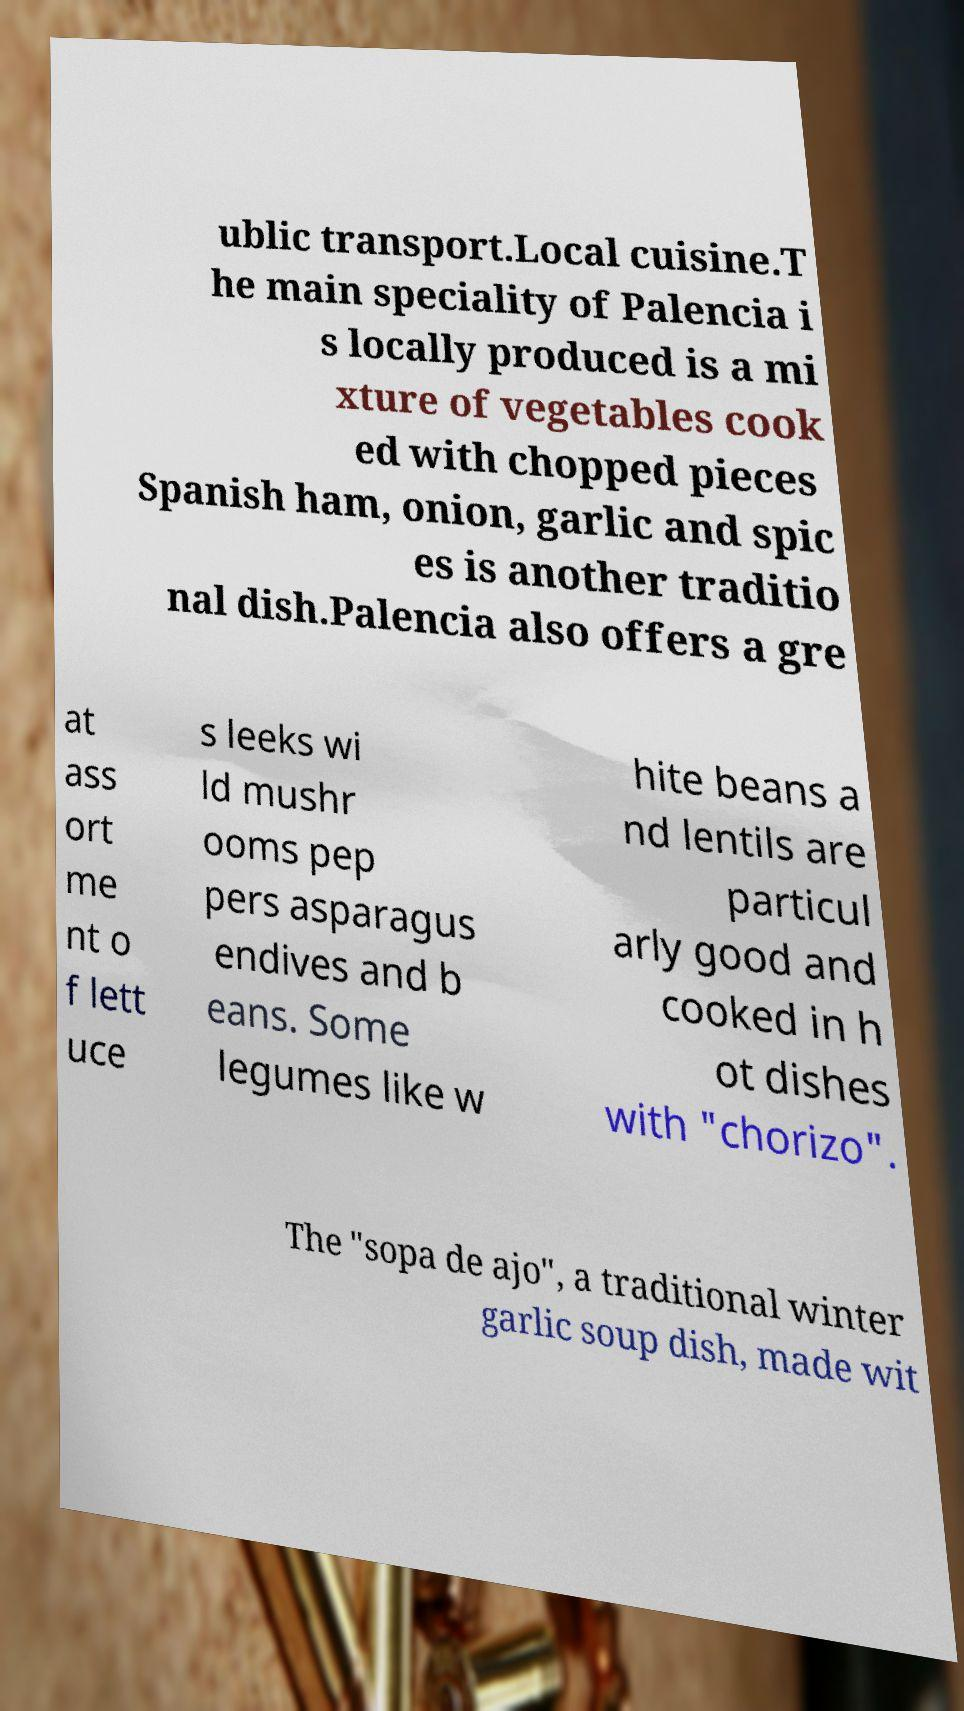Please identify and transcribe the text found in this image. ublic transport.Local cuisine.T he main speciality of Palencia i s locally produced is a mi xture of vegetables cook ed with chopped pieces Spanish ham, onion, garlic and spic es is another traditio nal dish.Palencia also offers a gre at ass ort me nt o f lett uce s leeks wi ld mushr ooms pep pers asparagus endives and b eans. Some legumes like w hite beans a nd lentils are particul arly good and cooked in h ot dishes with "chorizo". The "sopa de ajo", a traditional winter garlic soup dish, made wit 